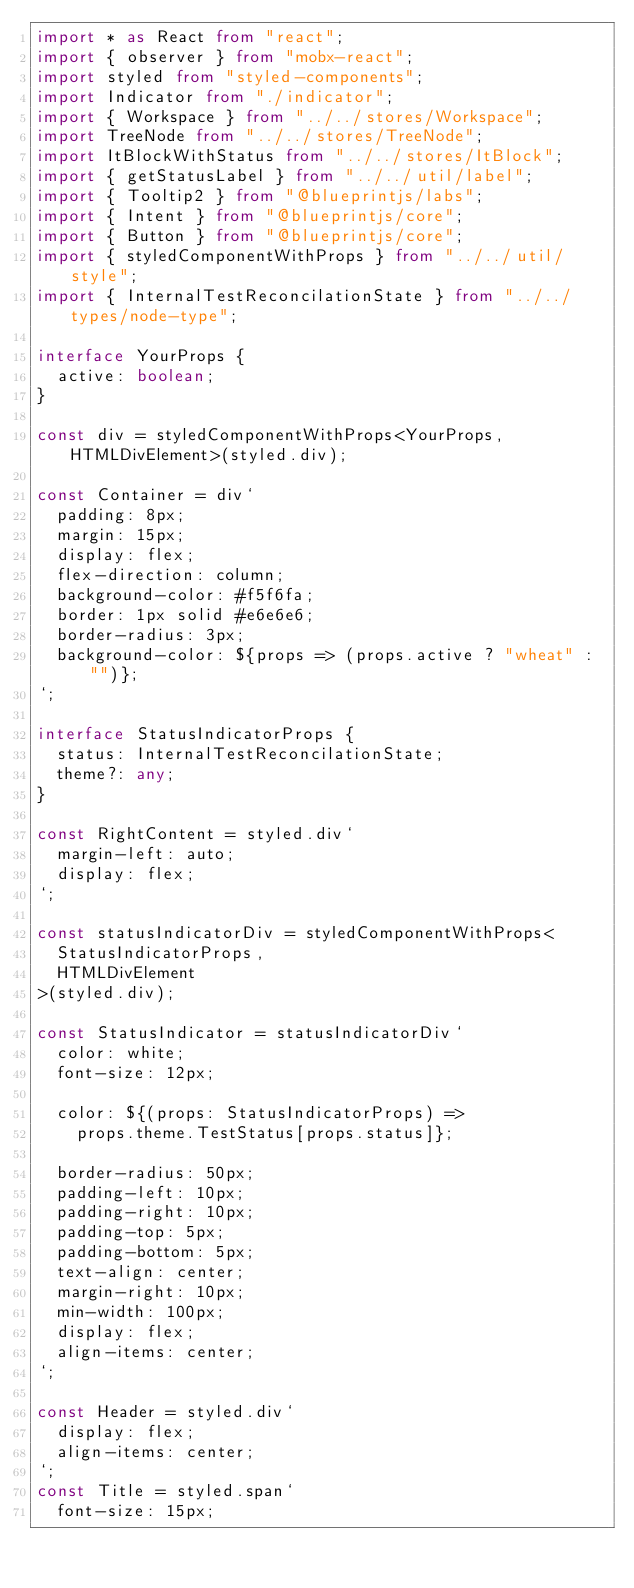<code> <loc_0><loc_0><loc_500><loc_500><_TypeScript_>import * as React from "react";
import { observer } from "mobx-react";
import styled from "styled-components";
import Indicator from "./indicator";
import { Workspace } from "../../stores/Workspace";
import TreeNode from "../../stores/TreeNode";
import ItBlockWithStatus from "../../stores/ItBlock";
import { getStatusLabel } from "../../util/label";
import { Tooltip2 } from "@blueprintjs/labs";
import { Intent } from "@blueprintjs/core";
import { Button } from "@blueprintjs/core";
import { styledComponentWithProps } from "../../util/style";
import { InternalTestReconcilationState } from "../../types/node-type";

interface YourProps {
  active: boolean;
}

const div = styledComponentWithProps<YourProps, HTMLDivElement>(styled.div);

const Container = div`
  padding: 8px;
  margin: 15px;
  display: flex;
  flex-direction: column;
  background-color: #f5f6fa;
  border: 1px solid #e6e6e6;
  border-radius: 3px;
  background-color: ${props => (props.active ? "wheat" : "")};
`;

interface StatusIndicatorProps {
  status: InternalTestReconcilationState;
  theme?: any;
}

const RightContent = styled.div`
  margin-left: auto;
  display: flex;
`;

const statusIndicatorDiv = styledComponentWithProps<
  StatusIndicatorProps,
  HTMLDivElement
>(styled.div);

const StatusIndicator = statusIndicatorDiv`
  color: white;
  font-size: 12px;

  color: ${(props: StatusIndicatorProps) =>
    props.theme.TestStatus[props.status]};

  border-radius: 50px;
  padding-left: 10px;
  padding-right: 10px;
  padding-top: 5px;
  padding-bottom: 5px;
  text-align: center;
  margin-right: 10px;
  min-width: 100px;
  display: flex;
  align-items: center;
`;

const Header = styled.div`
  display: flex;
  align-items: center;
`;
const Title = styled.span`
  font-size: 15px;</code> 